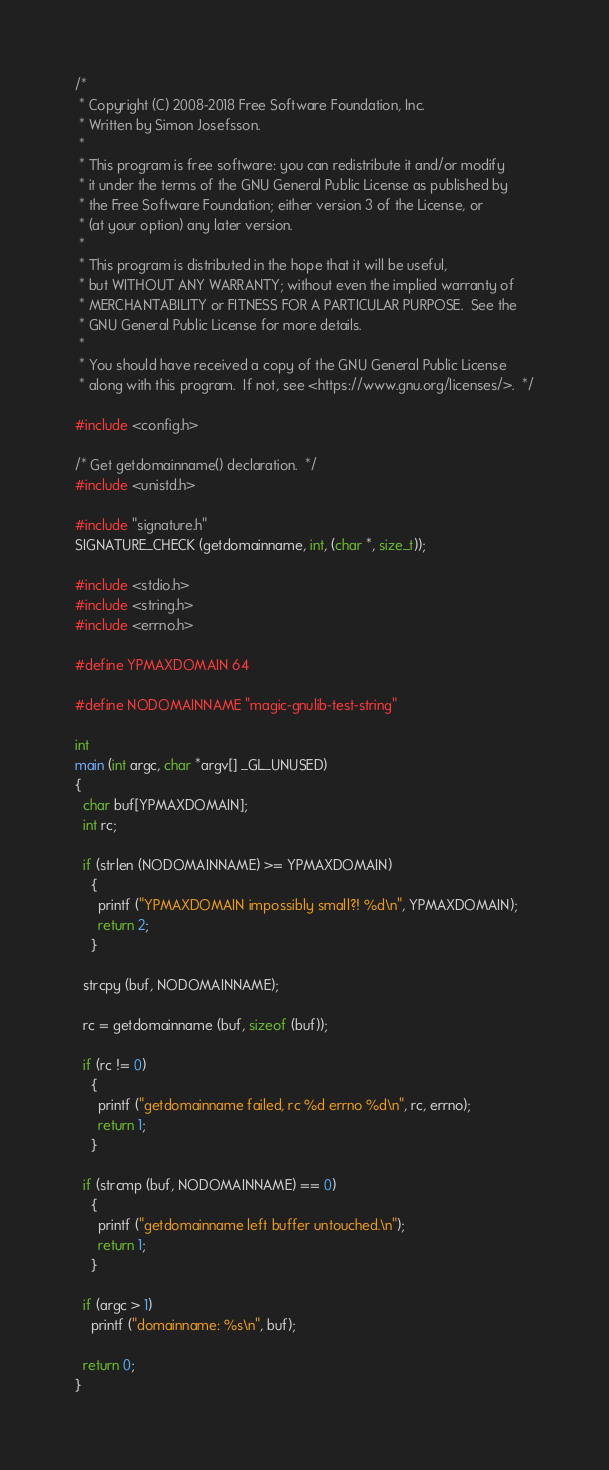<code> <loc_0><loc_0><loc_500><loc_500><_C_>/*
 * Copyright (C) 2008-2018 Free Software Foundation, Inc.
 * Written by Simon Josefsson.
 *
 * This program is free software: you can redistribute it and/or modify
 * it under the terms of the GNU General Public License as published by
 * the Free Software Foundation; either version 3 of the License, or
 * (at your option) any later version.
 *
 * This program is distributed in the hope that it will be useful,
 * but WITHOUT ANY WARRANTY; without even the implied warranty of
 * MERCHANTABILITY or FITNESS FOR A PARTICULAR PURPOSE.  See the
 * GNU General Public License for more details.
 *
 * You should have received a copy of the GNU General Public License
 * along with this program.  If not, see <https://www.gnu.org/licenses/>.  */

#include <config.h>

/* Get getdomainname() declaration.  */
#include <unistd.h>

#include "signature.h"
SIGNATURE_CHECK (getdomainname, int, (char *, size_t));

#include <stdio.h>
#include <string.h>
#include <errno.h>

#define YPMAXDOMAIN 64

#define NODOMAINNAME "magic-gnulib-test-string"

int
main (int argc, char *argv[] _GL_UNUSED)
{
  char buf[YPMAXDOMAIN];
  int rc;

  if (strlen (NODOMAINNAME) >= YPMAXDOMAIN)
    {
      printf ("YPMAXDOMAIN impossibly small?! %d\n", YPMAXDOMAIN);
      return 2;
    }

  strcpy (buf, NODOMAINNAME);

  rc = getdomainname (buf, sizeof (buf));

  if (rc != 0)
    {
      printf ("getdomainname failed, rc %d errno %d\n", rc, errno);
      return 1;
    }

  if (strcmp (buf, NODOMAINNAME) == 0)
    {
      printf ("getdomainname left buffer untouched.\n");
      return 1;
    }

  if (argc > 1)
    printf ("domainname: %s\n", buf);

  return 0;
}
</code> 